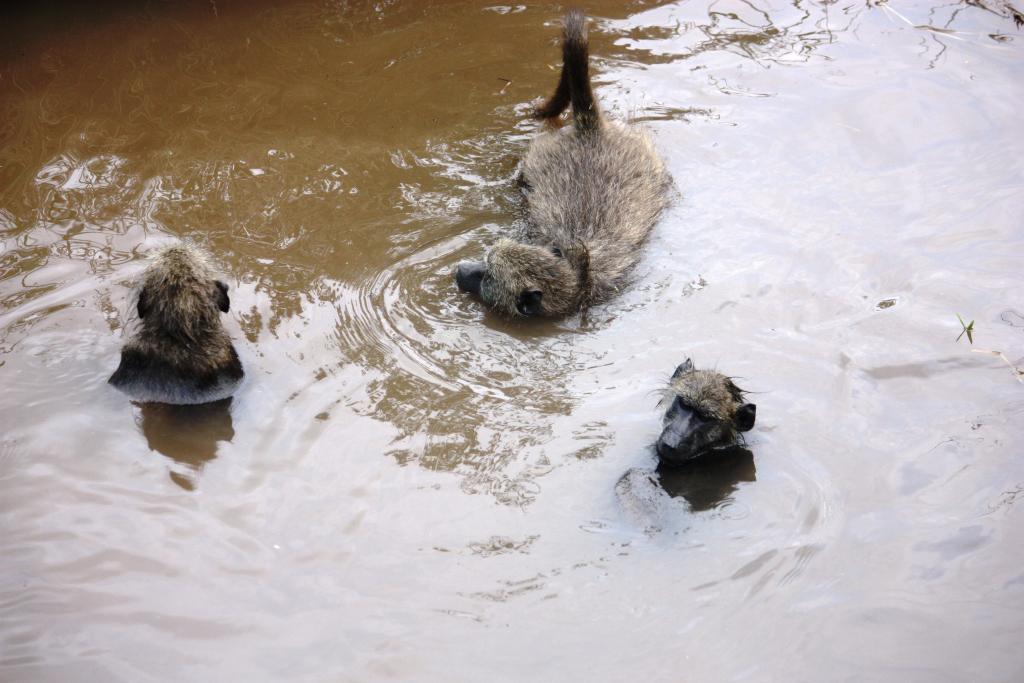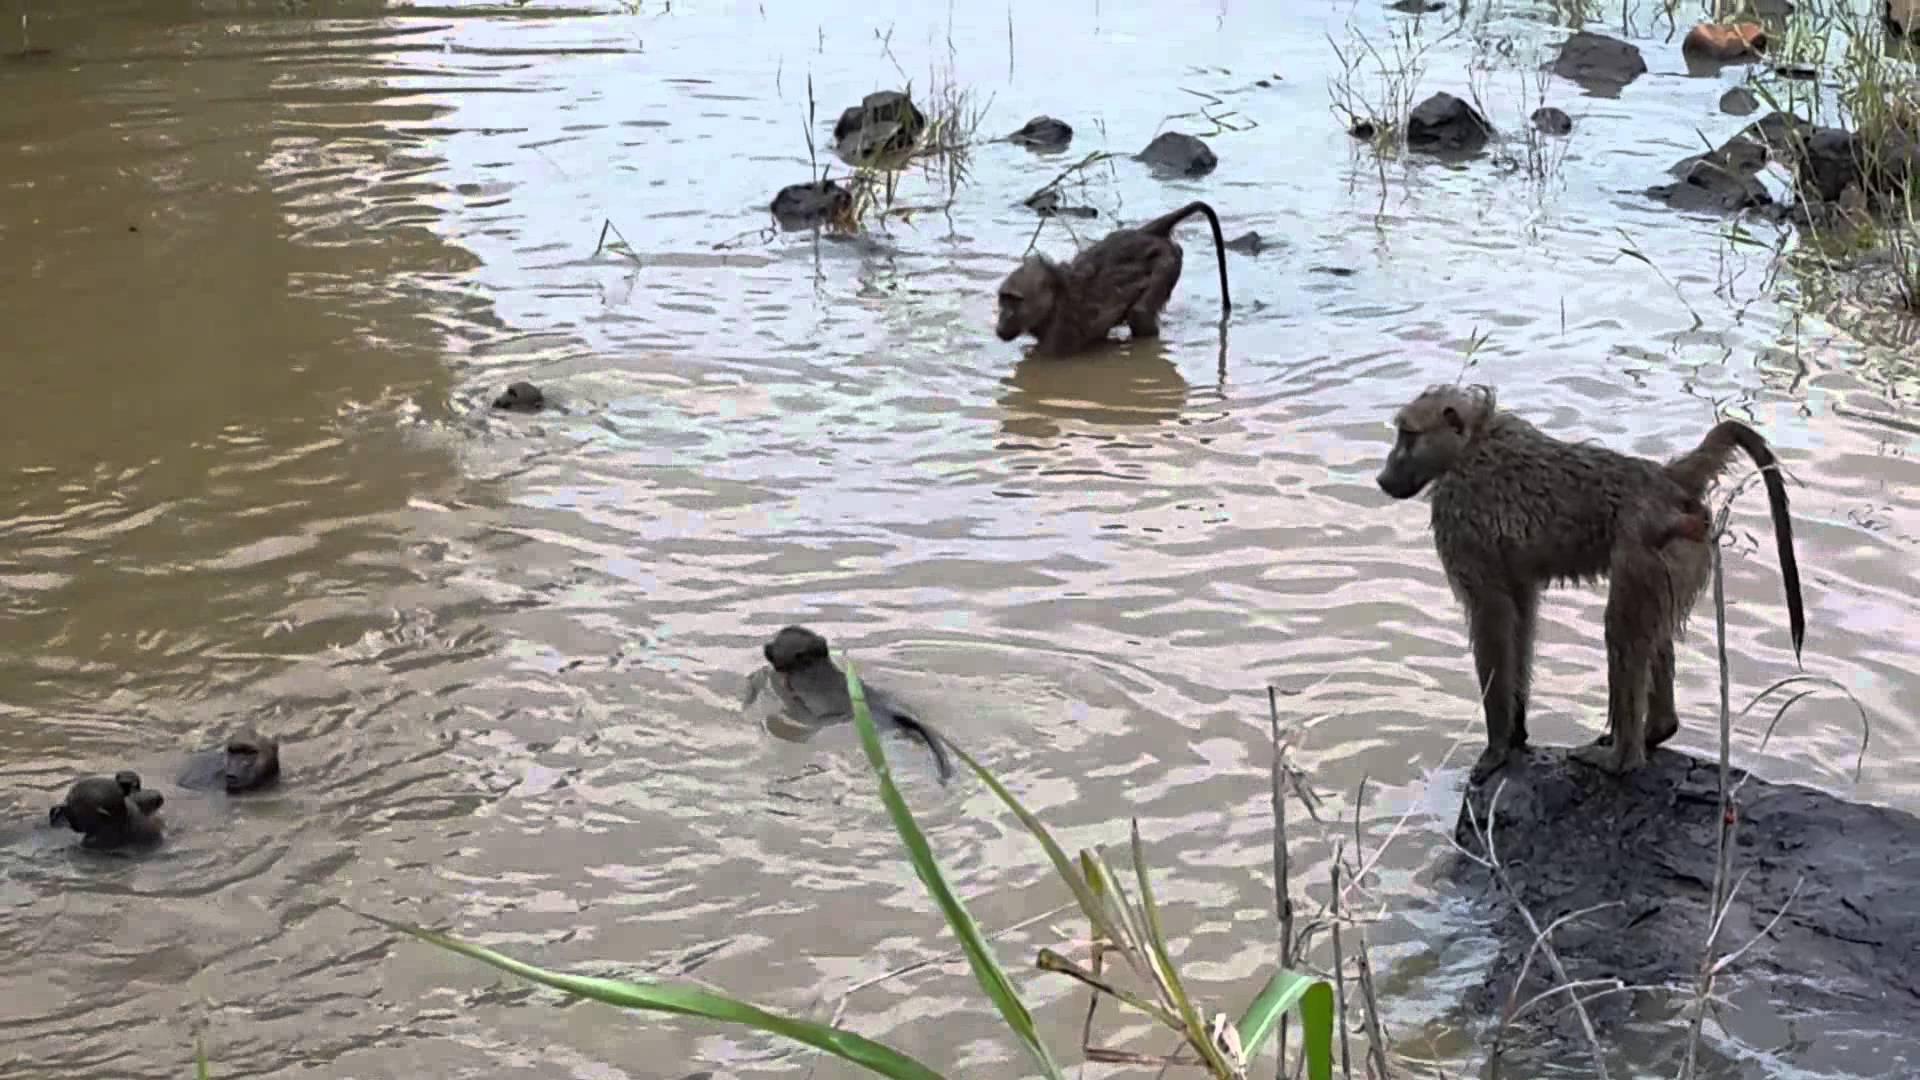The first image is the image on the left, the second image is the image on the right. Considering the images on both sides, is "There is a man-made swimming area with a square corner." valid? Answer yes or no. No. The first image is the image on the left, the second image is the image on the right. Assess this claim about the two images: "In one of the images, the pool is clearly man-made.". Correct or not? Answer yes or no. No. 